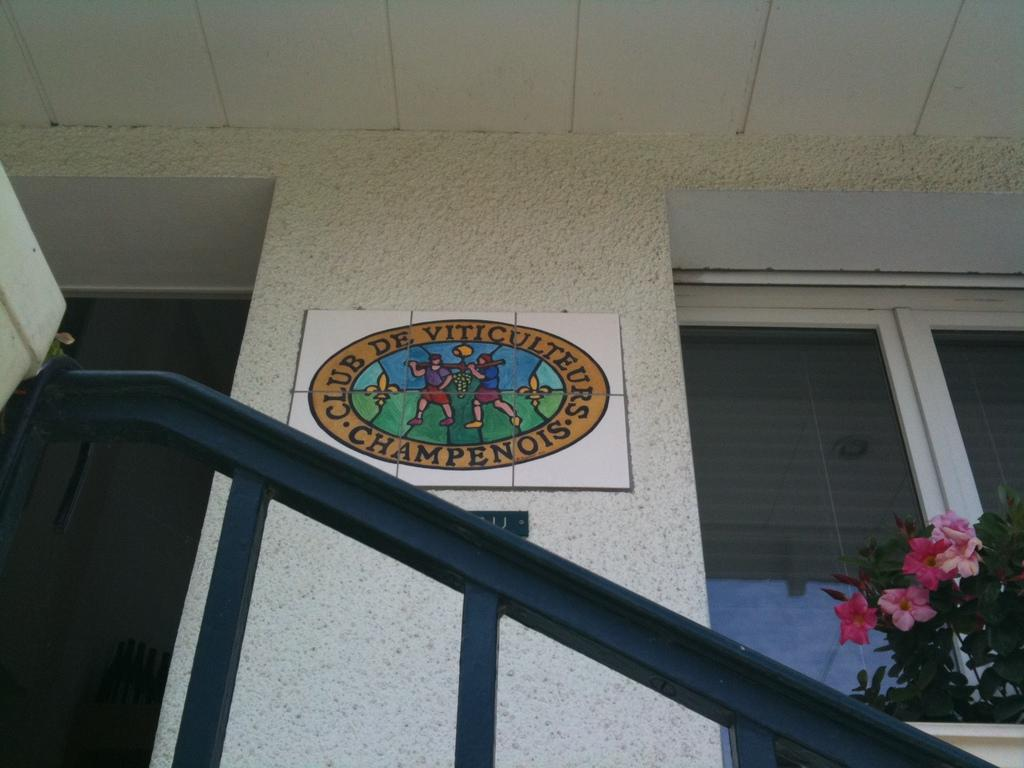What type of structure can be seen in the image? There is a wall in the image. What objects are made of wood in the image? There are boards in the image. What objects are used for drinking in the image? There are glasses in the image. What type of living organisms are present in the image? There are plants and flowers in the image. What type of beetle can be seen crawling on the wall in the image? There is no beetle present in the image; only the wall, boards, glasses, plants, and flowers are visible. 